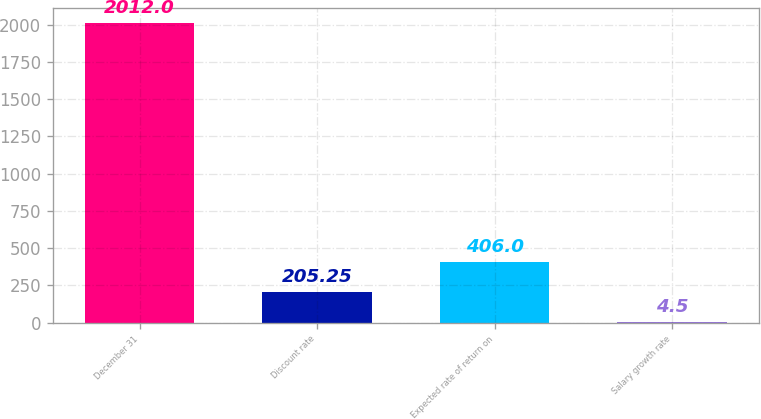Convert chart to OTSL. <chart><loc_0><loc_0><loc_500><loc_500><bar_chart><fcel>December 31<fcel>Discount rate<fcel>Expected rate of return on<fcel>Salary growth rate<nl><fcel>2012<fcel>205.25<fcel>406<fcel>4.5<nl></chart> 